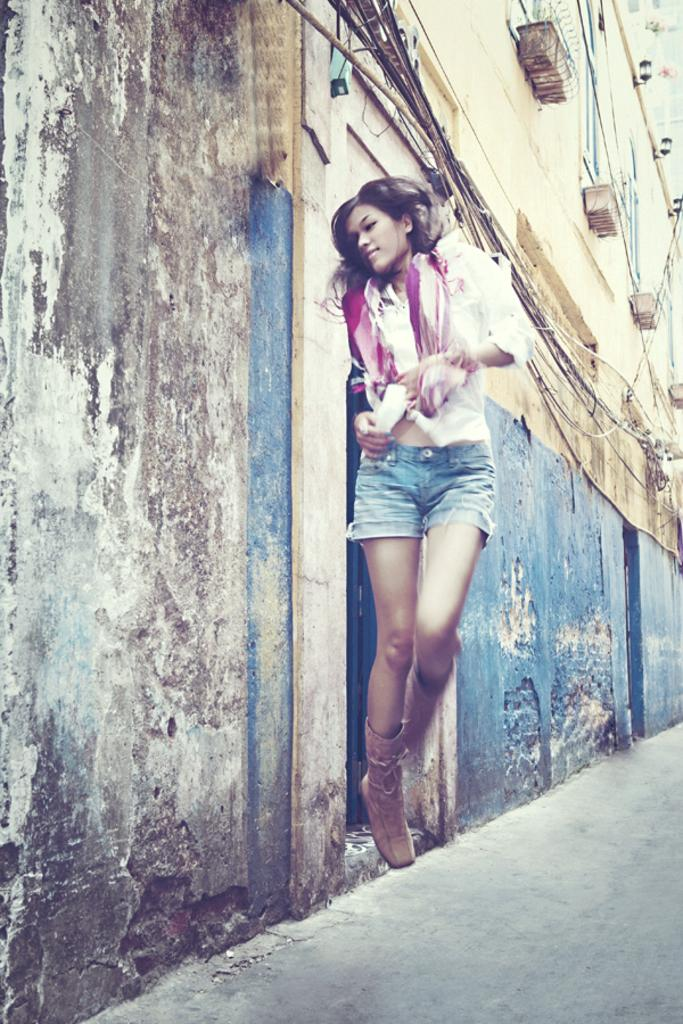Who is present in the image? There is a woman in the picture. What is the woman wearing on her upper body? The woman is wearing a shirt. What is the woman wearing on her lower body? The woman is wearing jeans. What can be seen in the background of the picture? There is a wall in the background of the picture. What type of toothbrush is the woman holding in the picture? There is no toothbrush present in the image; the woman is not holding any object. 